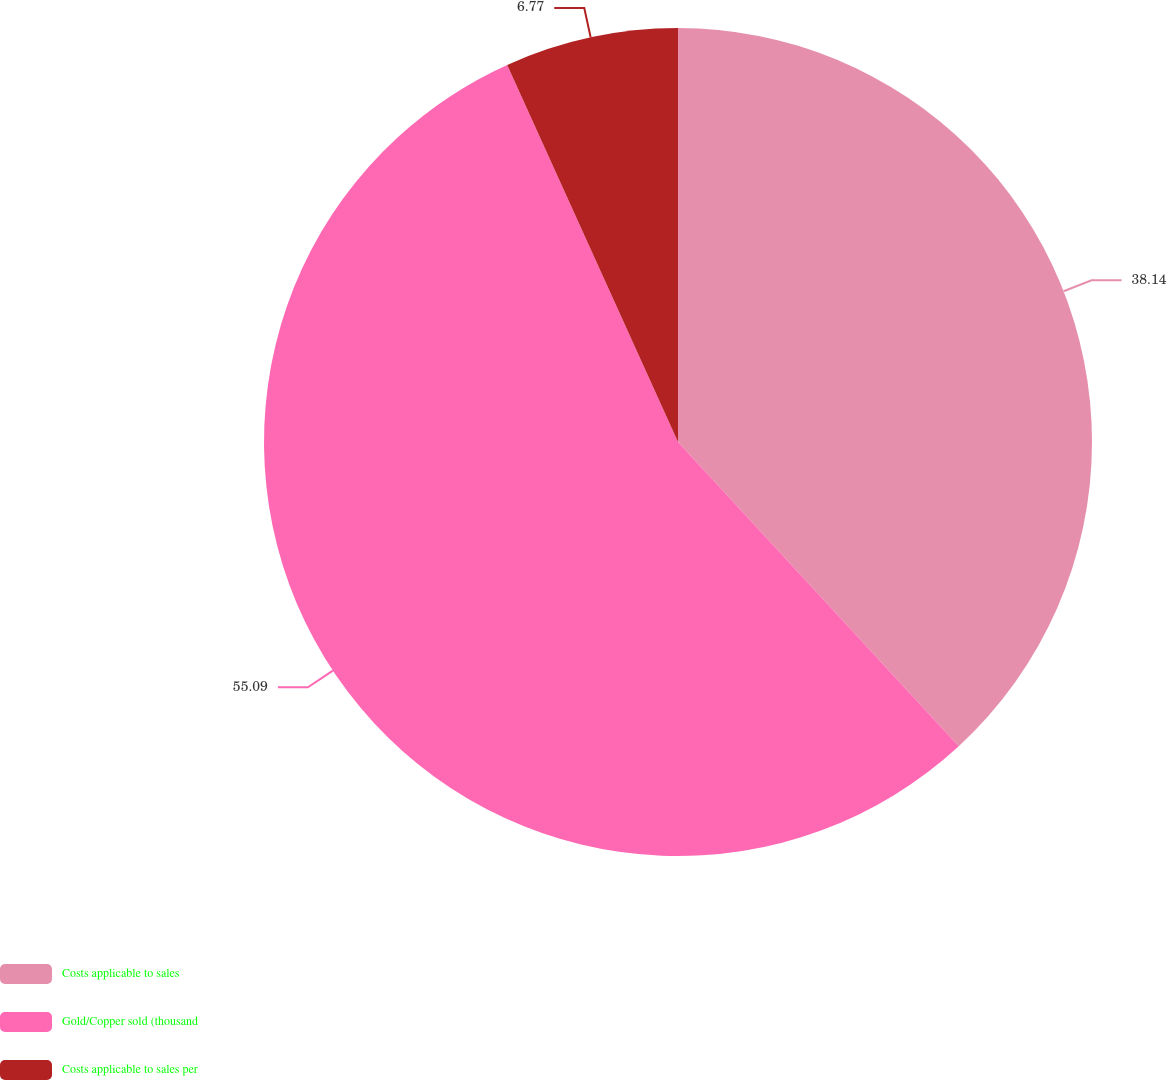<chart> <loc_0><loc_0><loc_500><loc_500><pie_chart><fcel>Costs applicable to sales<fcel>Gold/Copper sold (thousand<fcel>Costs applicable to sales per<nl><fcel>38.14%<fcel>55.09%<fcel>6.77%<nl></chart> 